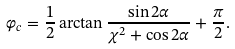<formula> <loc_0><loc_0><loc_500><loc_500>\varphi _ { c } = \frac { 1 } { 2 } \arctan \frac { \sin 2 \alpha } { \chi ^ { 2 } + \cos 2 \alpha } + \frac { \pi } { 2 } .</formula> 